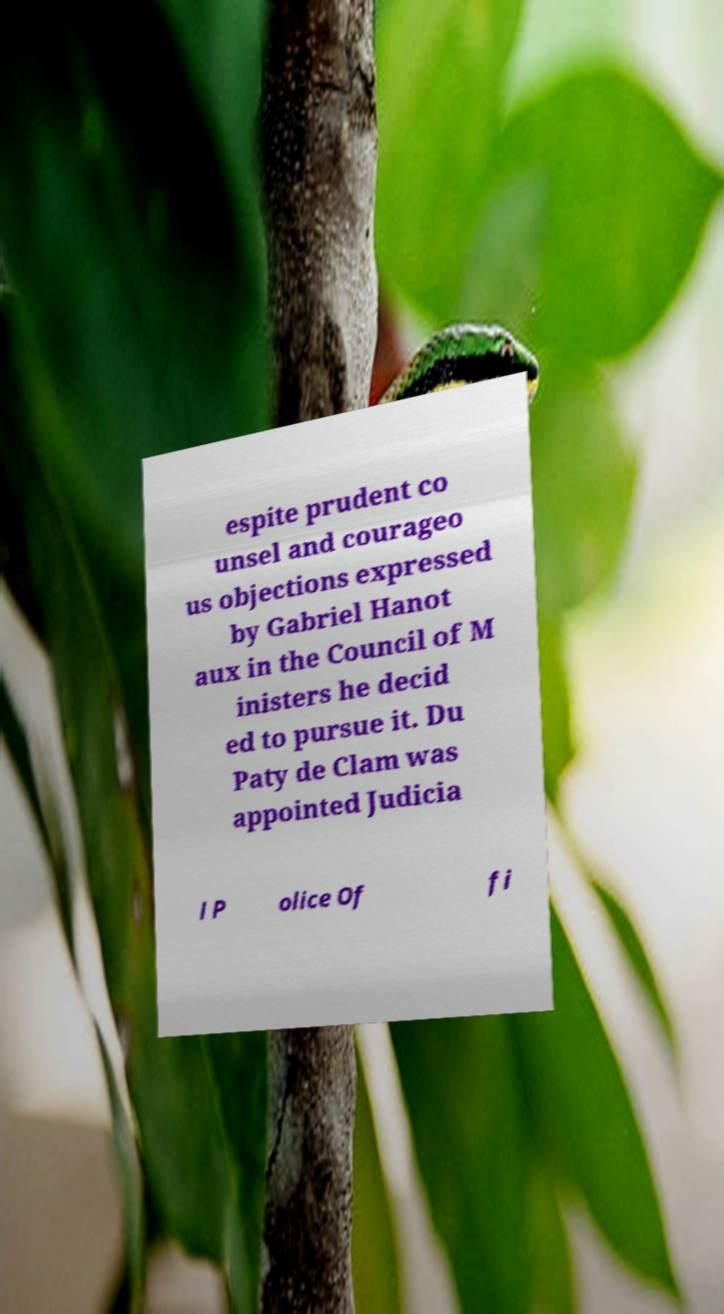Can you accurately transcribe the text from the provided image for me? espite prudent co unsel and courageo us objections expressed by Gabriel Hanot aux in the Council of M inisters he decid ed to pursue it. Du Paty de Clam was appointed Judicia l P olice Of fi 